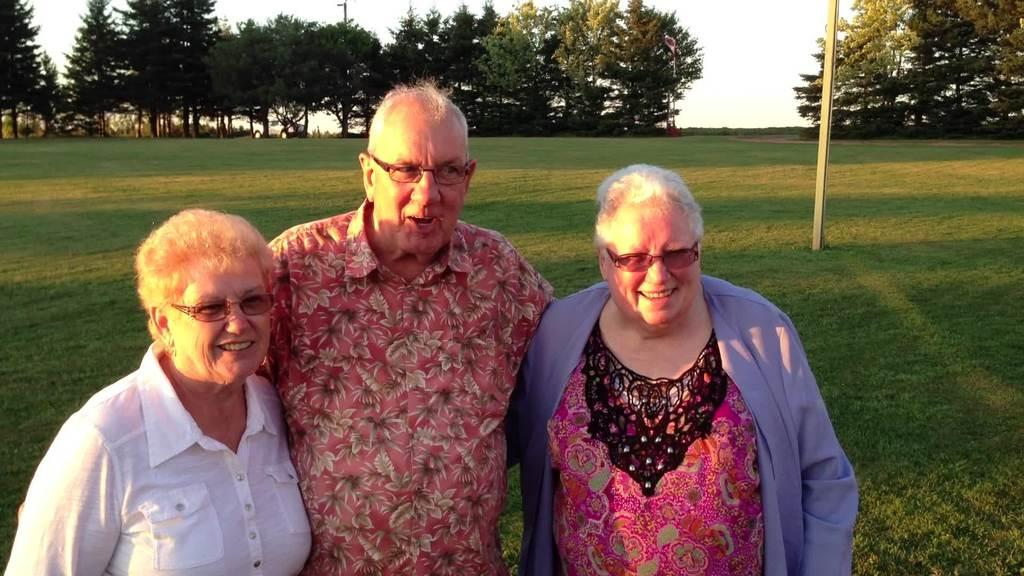What can be seen in the front of the image? There are persons standing in the front of the image. What is the facial expression of the persons in the image? The persons are smiling. What type of ground is visible in the center of the image? There is grass on the ground in the center of the image. What is located in the center of the image? There is a pole in the center of the image. What can be seen in the background of the image? There are trees in the background of the image. What type of watch is the person wearing in the image? There is no watch visible on any person in the image. What thrilling activity are the persons participating in, as seen in the image? The image does not depict any specific activity or thrilling event; it simply shows persons standing and smiling. 